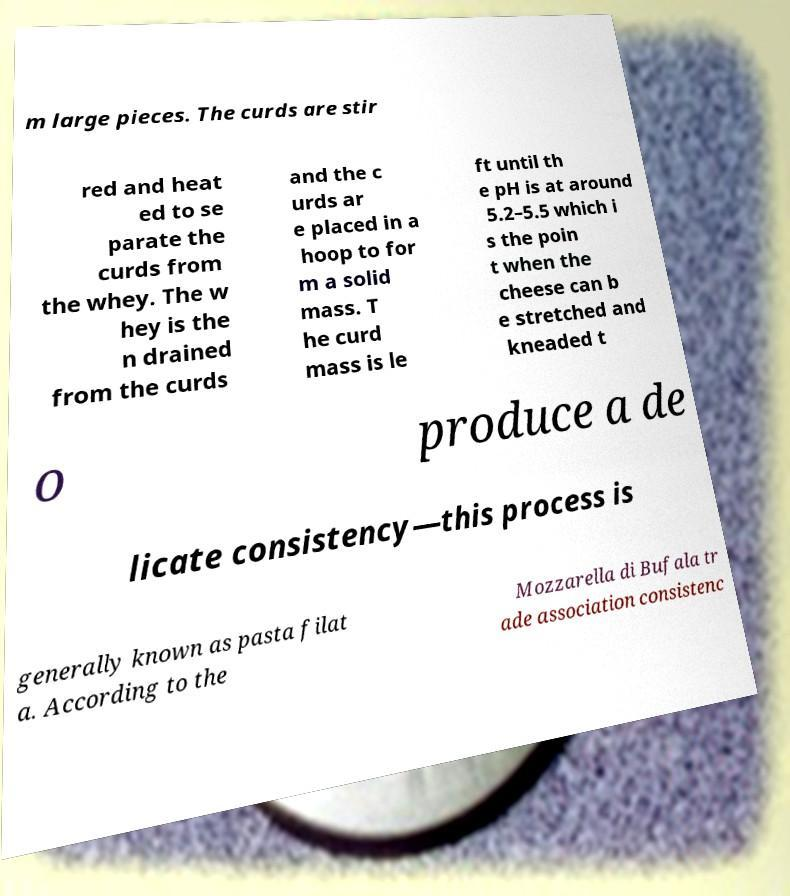Could you extract and type out the text from this image? m large pieces. The curds are stir red and heat ed to se parate the curds from the whey. The w hey is the n drained from the curds and the c urds ar e placed in a hoop to for m a solid mass. T he curd mass is le ft until th e pH is at around 5.2–5.5 which i s the poin t when the cheese can b e stretched and kneaded t o produce a de licate consistency—this process is generally known as pasta filat a. According to the Mozzarella di Bufala tr ade association consistenc 